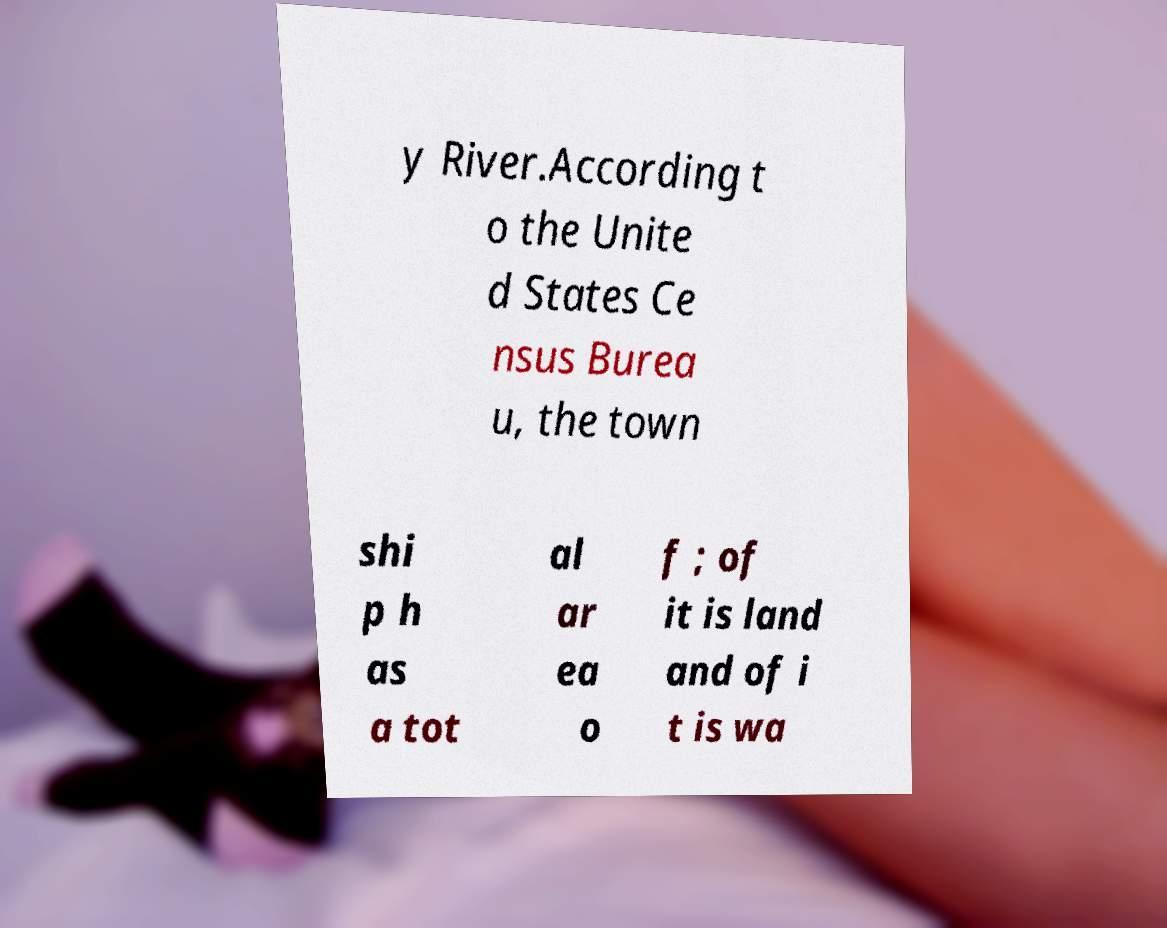Please identify and transcribe the text found in this image. y River.According t o the Unite d States Ce nsus Burea u, the town shi p h as a tot al ar ea o f ; of it is land and of i t is wa 